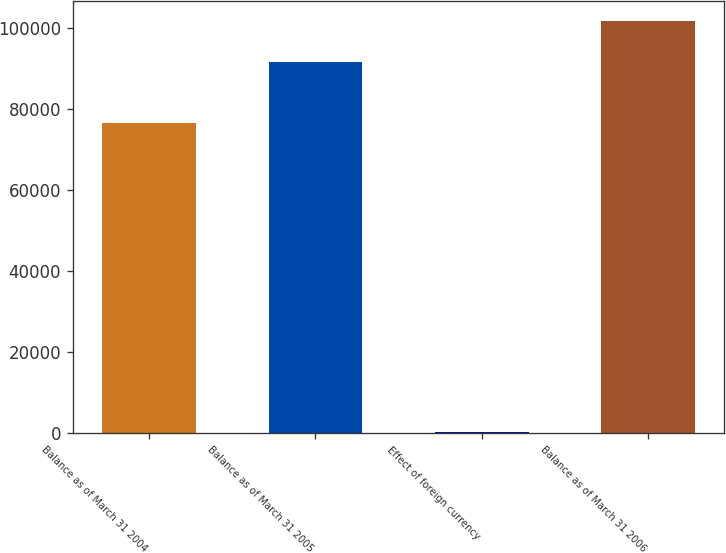<chart> <loc_0><loc_0><loc_500><loc_500><bar_chart><fcel>Balance as of March 31 2004<fcel>Balance as of March 31 2005<fcel>Effect of foreign currency<fcel>Balance as of March 31 2006<nl><fcel>76493<fcel>91661<fcel>207<fcel>101685<nl></chart> 